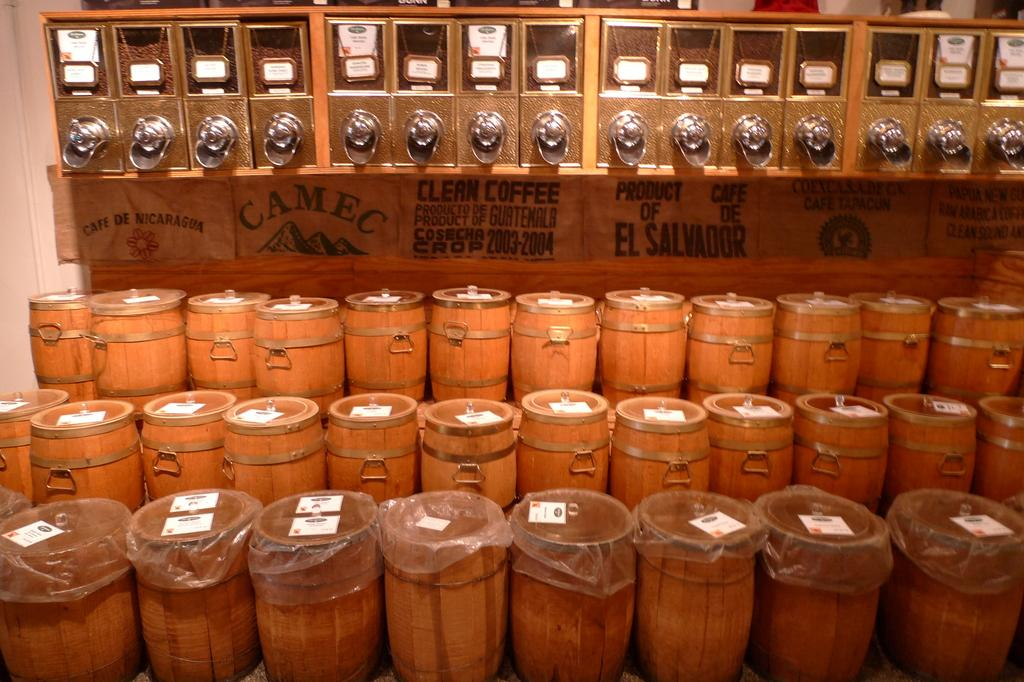What musical instruments are present in the image? There are drums in the middle and bottom of the image. Where are the drums located in the image? The drums are in the middle and bottom of the image. What other objects can be seen at the top of the image? There are boxes at the top of the image. What type of copper note is being played on the guitar in the image? There is no guitar or copper note present in the image. 